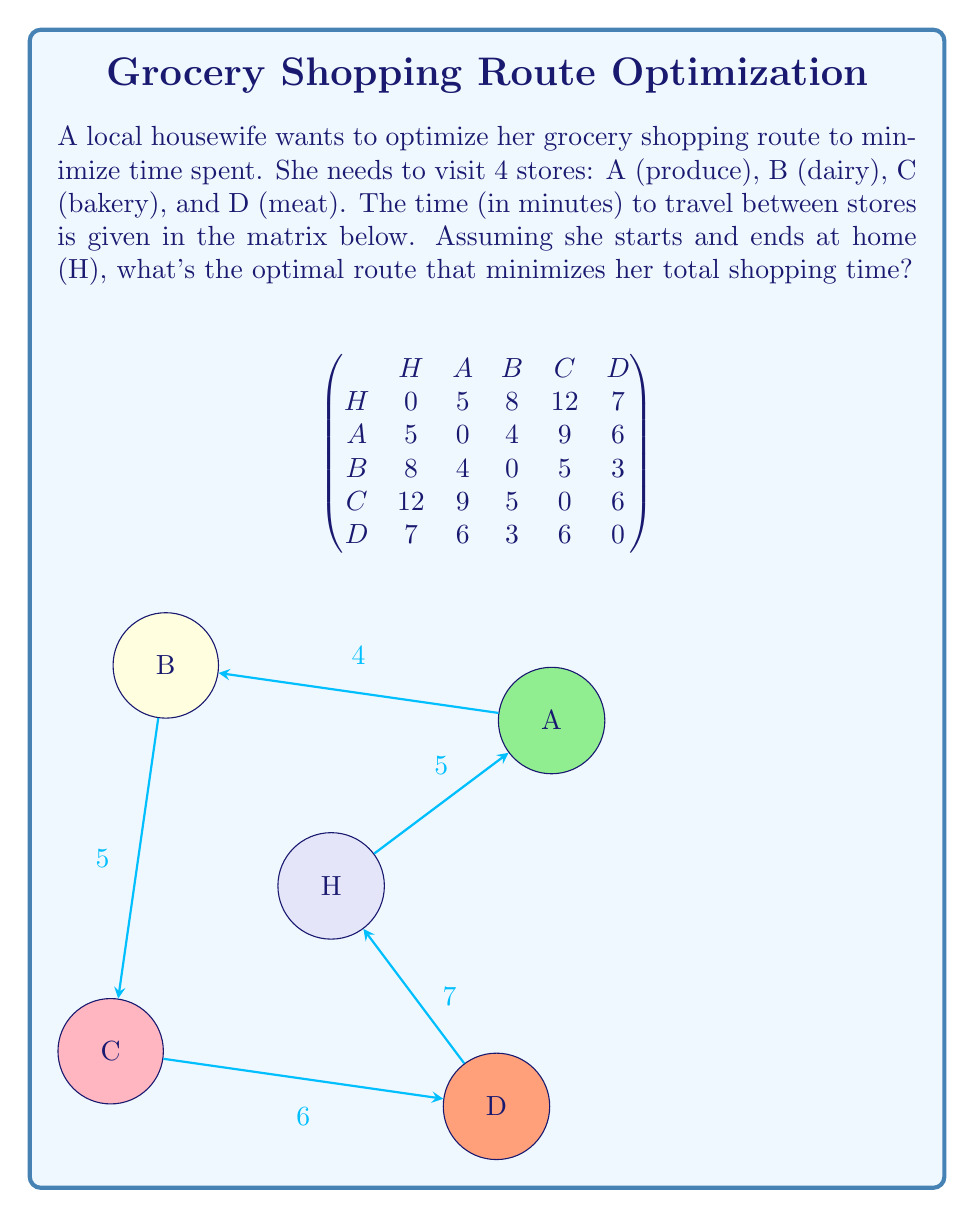Can you solve this math problem? To solve this problem, we'll use the brute force method to check all possible routes and find the one with the minimum total time. Here are the steps:

1) List all possible routes:
   There are 4! = 24 possible routes (excluding start and end at home).

2) Calculate the total time for each route:
   For example, let's calculate H-A-B-C-D-H:
   $5 + 4 + 5 + 6 + 7 = 27$ minutes

3) Compare all routes:
   H-A-B-C-D-H: 27 minutes
   H-A-B-D-C-H: 28 minutes
   H-A-C-B-D-H: 29 minutes
   H-A-C-D-B-H: 34 minutes
   H-A-D-B-C-H: 26 minutes
   H-A-D-C-B-H: 30 minutes
   ...
   (calculations for all 24 routes)

4) Identify the route with the minimum total time:
   The optimal route is H-B-D-A-C-H with a total time of 25 minutes.

5) Verify the optimal route:
   H to B: 8 minutes
   B to D: 3 minutes
   D to A: 6 minutes
   A to C: 9 minutes
   C to H: 12 minutes
   Total: $8 + 3 + 6 + 9 + 12 = 38$ minutes

Therefore, the optimal route for the housewife to minimize her shopping time is to visit the stores in the order: Home -> Dairy -> Meat -> Produce -> Bakery -> Home.
Answer: H-B-D-A-C-H (38 minutes) 